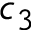Convert formula to latex. <formula><loc_0><loc_0><loc_500><loc_500>c _ { 3 }</formula> 